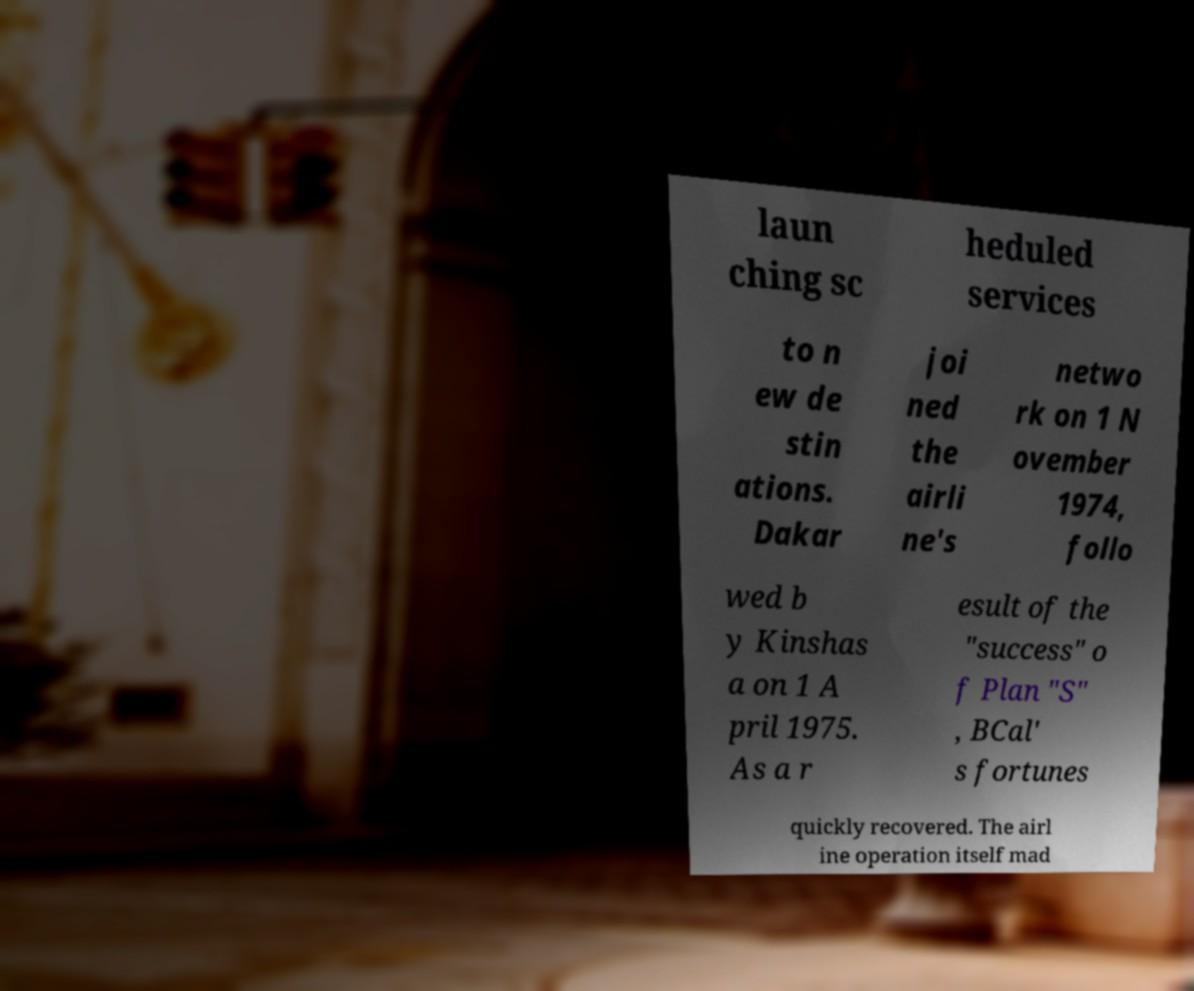Please read and relay the text visible in this image. What does it say? laun ching sc heduled services to n ew de stin ations. Dakar joi ned the airli ne's netwo rk on 1 N ovember 1974, follo wed b y Kinshas a on 1 A pril 1975. As a r esult of the "success" o f Plan "S" , BCal' s fortunes quickly recovered. The airl ine operation itself mad 